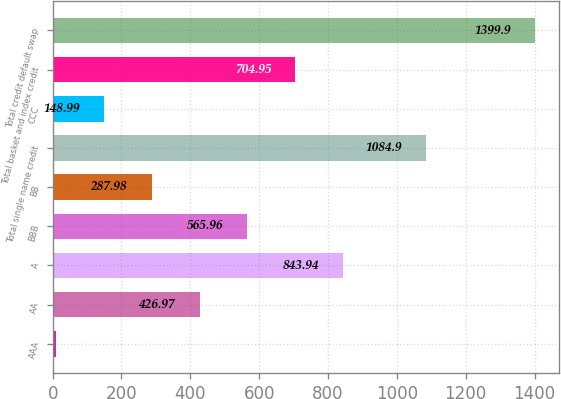Convert chart to OTSL. <chart><loc_0><loc_0><loc_500><loc_500><bar_chart><fcel>AAA<fcel>AA<fcel>A<fcel>BBB<fcel>BB<fcel>Total single name credit<fcel>CCC<fcel>Total basket and index credit<fcel>Total credit default swap<nl><fcel>10<fcel>426.97<fcel>843.94<fcel>565.96<fcel>287.98<fcel>1084.9<fcel>148.99<fcel>704.95<fcel>1399.9<nl></chart> 